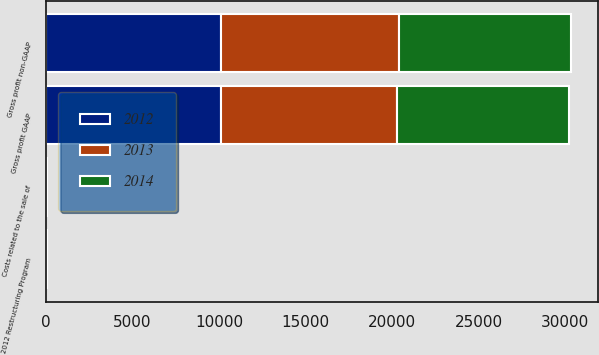<chart> <loc_0><loc_0><loc_500><loc_500><stacked_bar_chart><ecel><fcel>Gross profit GAAP<fcel>2012 Restructuring Program<fcel>Costs related to the sale of<fcel>Gross profit non-GAAP<nl><fcel>2012<fcel>10109<fcel>29<fcel>4<fcel>10142<nl><fcel>2013<fcel>10201<fcel>32<fcel>15<fcel>10248<nl><fcel>2014<fcel>9932<fcel>2<fcel>24<fcel>9963<nl></chart> 